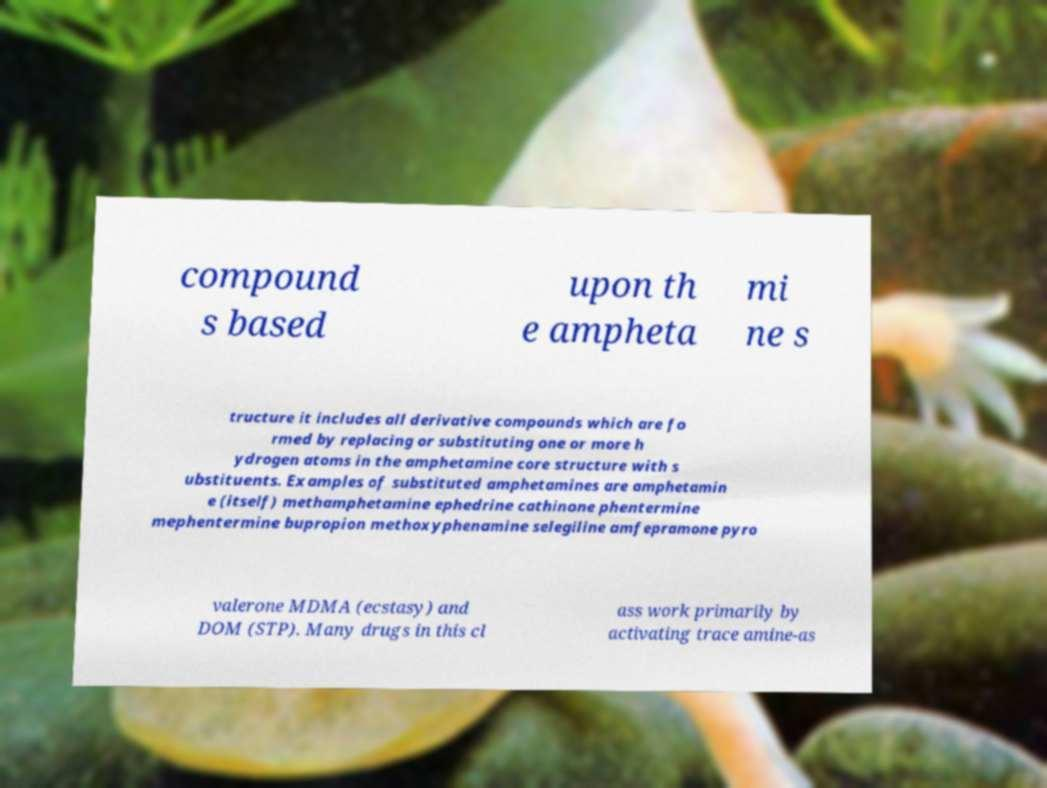Could you assist in decoding the text presented in this image and type it out clearly? compound s based upon th e ampheta mi ne s tructure it includes all derivative compounds which are fo rmed by replacing or substituting one or more h ydrogen atoms in the amphetamine core structure with s ubstituents. Examples of substituted amphetamines are amphetamin e (itself) methamphetamine ephedrine cathinone phentermine mephentermine bupropion methoxyphenamine selegiline amfepramone pyro valerone MDMA (ecstasy) and DOM (STP). Many drugs in this cl ass work primarily by activating trace amine-as 